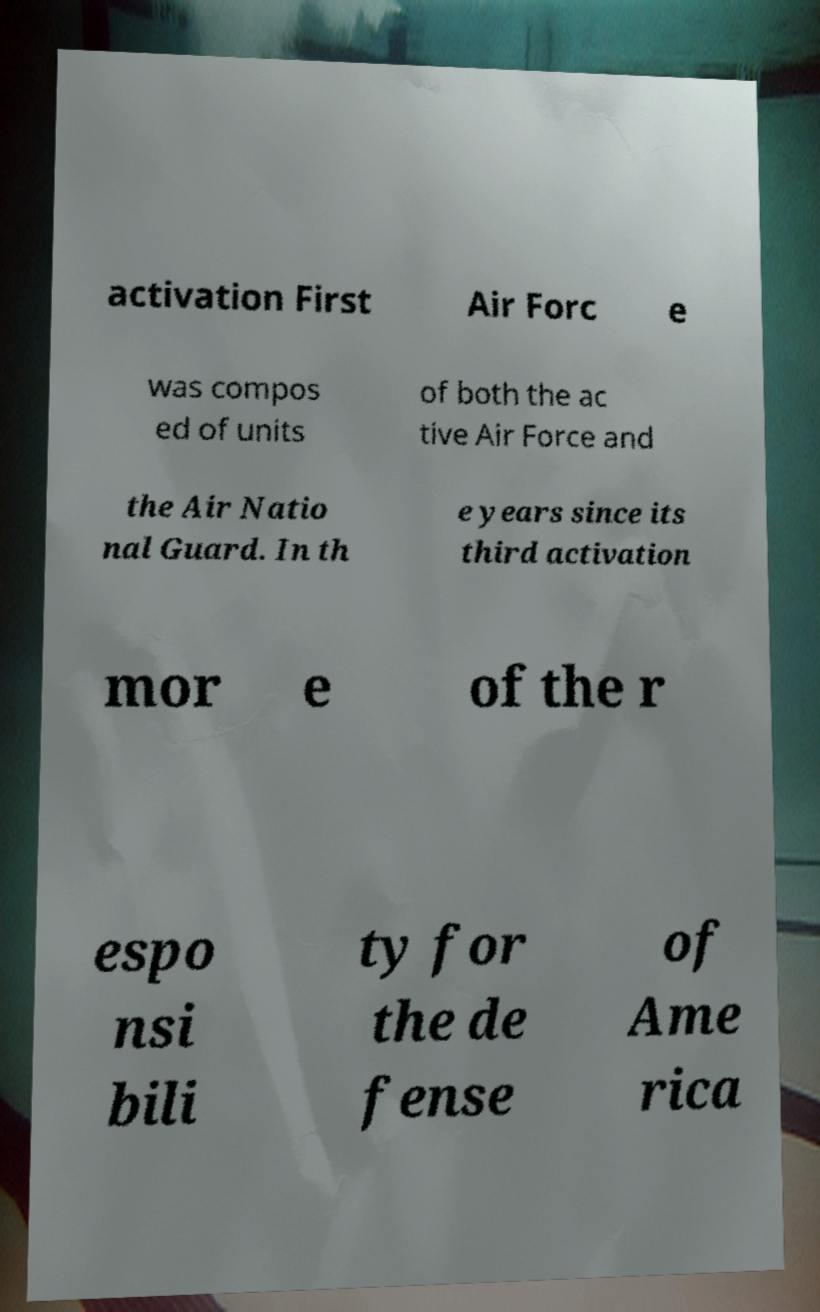For documentation purposes, I need the text within this image transcribed. Could you provide that? activation First Air Forc e was compos ed of units of both the ac tive Air Force and the Air Natio nal Guard. In th e years since its third activation mor e of the r espo nsi bili ty for the de fense of Ame rica 